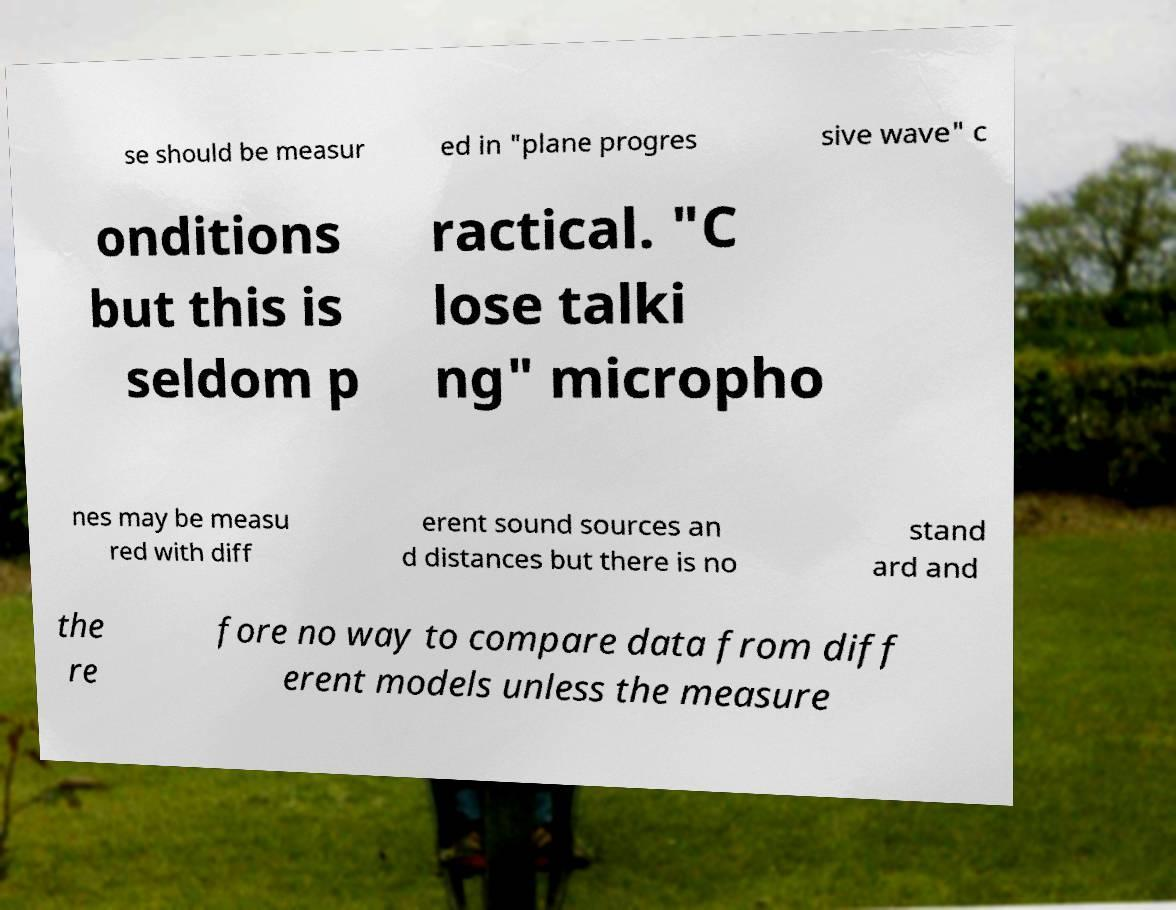Could you extract and type out the text from this image? se should be measur ed in "plane progres sive wave" c onditions but this is seldom p ractical. "C lose talki ng" micropho nes may be measu red with diff erent sound sources an d distances but there is no stand ard and the re fore no way to compare data from diff erent models unless the measure 